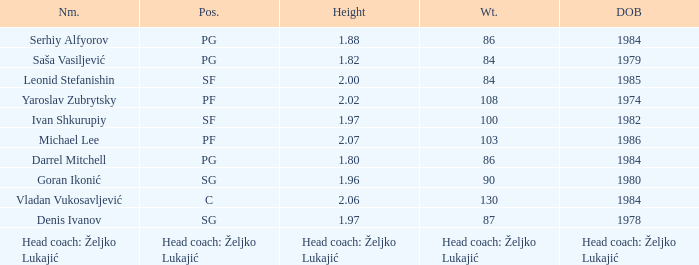What is the weight of the player with a height of 2.00m? 84.0. 